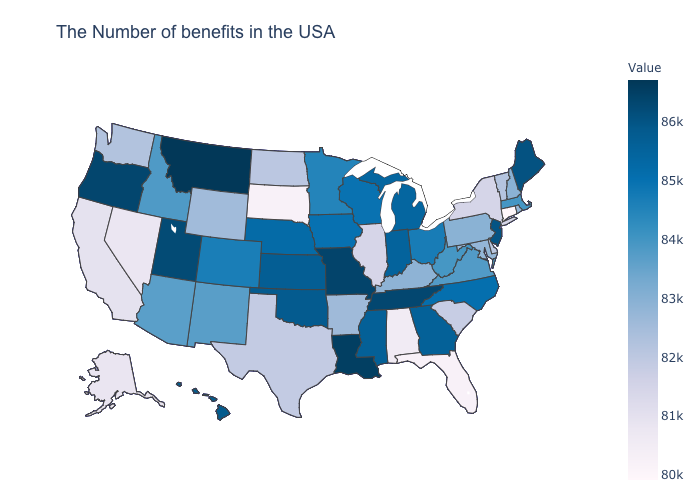Among the states that border Minnesota , does South Dakota have the lowest value?
Short answer required. Yes. Among the states that border South Carolina , does North Carolina have the lowest value?
Concise answer only. Yes. Among the states that border New Hampshire , does Massachusetts have the highest value?
Write a very short answer. No. Does Rhode Island have a higher value than Indiana?
Concise answer only. No. Does Connecticut have the lowest value in the USA?
Concise answer only. Yes. Among the states that border Kansas , does Missouri have the highest value?
Keep it brief. Yes. 